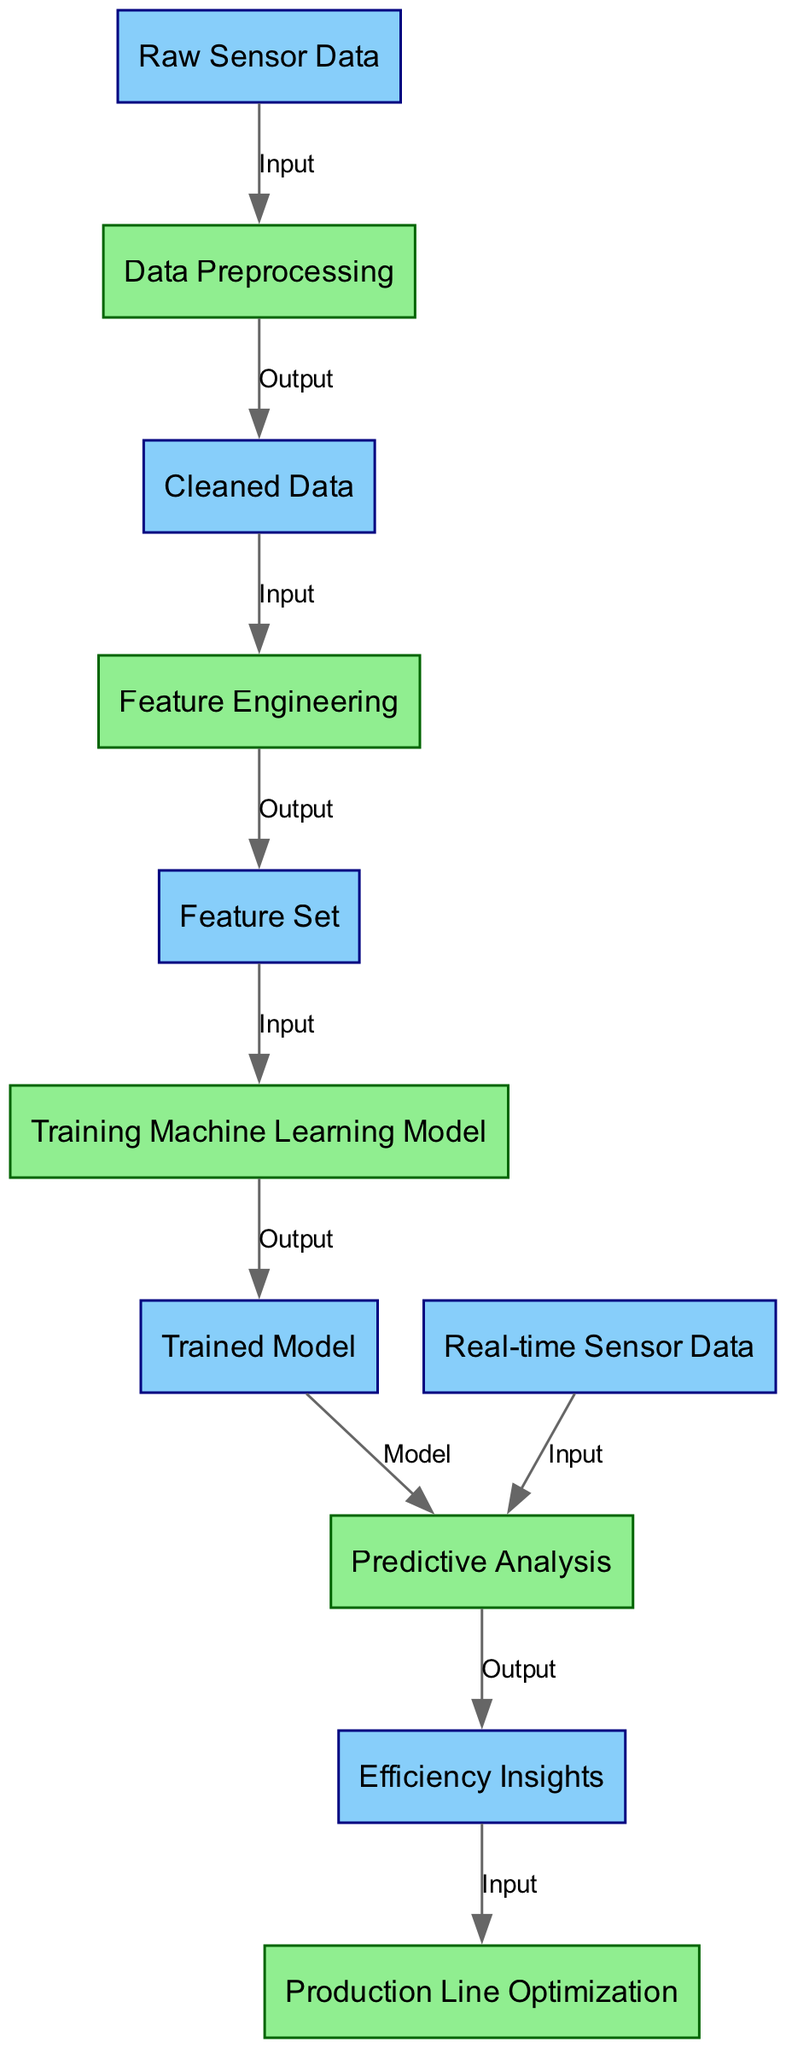What is the starting point of the diagram? The starting point is labeled "Raw Sensor Data," which is the first node before any processing occurs. This indicates that the analysis begins with the collection of raw sensor data.
Answer: Raw Sensor Data How many processes are included in the diagram? The diagram includes five processes. These are "Data Preprocessing," "Feature Engineering," "Training Machine Learning Model," "Predictive Analysis," and "Production Line Optimization."
Answer: 5 What type of data is produced after "Data Preprocessing"? After "Data Preprocessing," the output is labeled "Cleaned Data," indicating that the raw sensor data has been processed and cleaned for further analysis.
Answer: Cleaned Data Which two nodes are connected by a "Model" relationship? The "Training Machine Learning Model" node is connected to the "Predictive Analysis" node by a "Model" relationship. This signifies that the trained model is used for predictive analysis based on the real-time sensor data.
Answer: Training Machine Learning Model and Predictive Analysis What information does "Efficiency Insights" provide? "Efficiency Insights" represents the output from "Predictive Analysis." This node signifies that the analysis conducted leads to insights regarding production line efficiency, facilitating better decision-making.
Answer: Efficiency Insights What data is required as input for "Predictive Analysis"? "Predictive Analysis" requires both "Real-time Sensor Data" and the "Trained Model" as inputs. This indicates that analysis depends on both current data and the insights from the previous training of the model.
Answer: Real-time Sensor Data and Trained Model Which process follows after obtaining "Efficiency Insights"? The process that follows "Efficiency Insights" is "Production Line Optimization." This indicates the progression from insights to actual improvements in the production line.
Answer: Production Line Optimization What is the final output of the entire process in the diagram? The final output of the diagram is represented by the last process "Production Line Optimization," which indicates that the insights gained are utilized to optimize the production line.
Answer: Production Line Optimization 